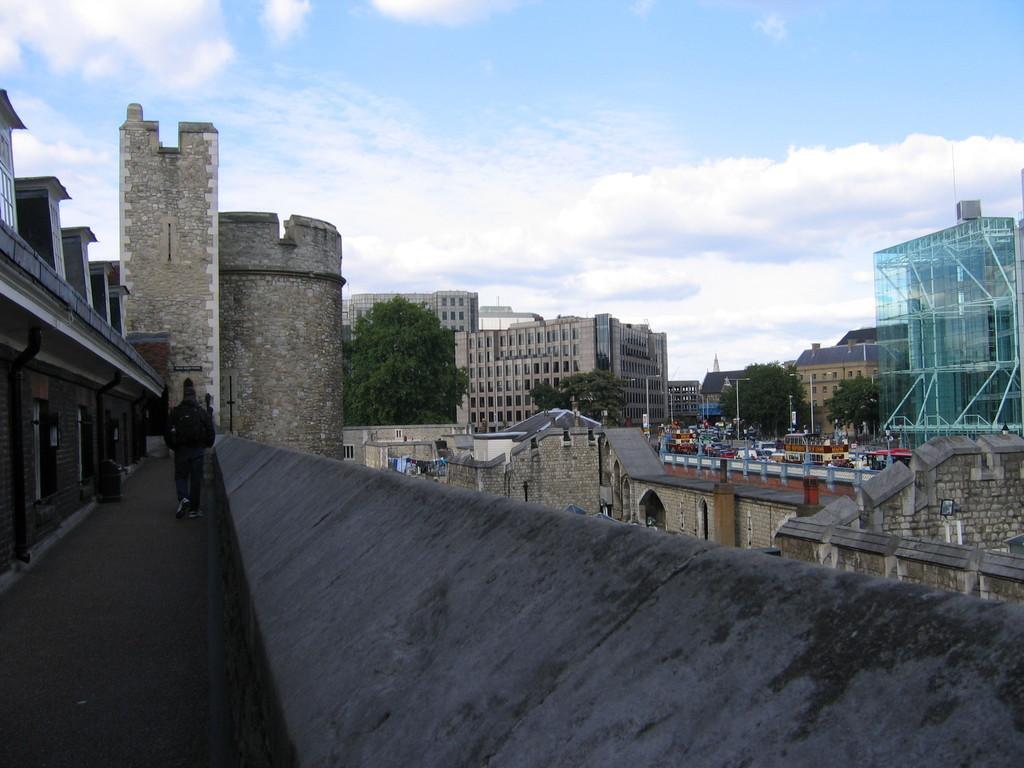Please provide a concise description of this image. In this picture we can see buildings, trees, poles, and vehicles. There are boards. Here we can see a person walking on the floor. In the background there is sky with clouds. 